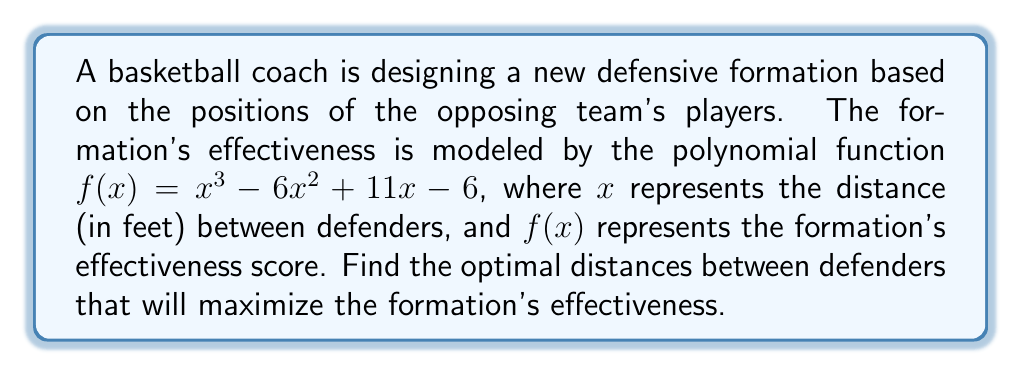Give your solution to this math problem. To find the optimal distances between defenders, we need to find the roots of the polynomial function $f(x) = x^3 - 6x^2 + 11x - 6$. These roots will give us the values of $x$ where the formation's effectiveness is zero, and the optimal distances will be between these values.

Let's solve this step-by-step:

1) First, we can try to factor out a common factor:
   $f(x) = x^3 - 6x^2 + 11x - 6$
   There are no common factors, so we move to the next step.

2) This is a cubic function, so let's try to guess one root. We can see that when $x = 1$, $f(1) = 1 - 6 + 11 - 6 = 0$. So, $(x - 1)$ is a factor.

3) We can use polynomial long division to divide $f(x)$ by $(x - 1)$:

   $x^3 - 6x^2 + 11x - 6 = (x - 1)(x^2 - 5x + 6)$

4) Now we need to factor the quadratic term $x^2 - 5x + 6$:
   $x^2 - 5x + 6 = (x - 2)(x - 3)$

5) Therefore, the fully factored polynomial is:
   $f(x) = (x - 1)(x - 2)(x - 3)$

6) The roots of the polynomial are the values that make each factor equal to zero:
   $x = 1$, $x = 2$, and $x = 3$

These roots represent the distances between defenders where the formation's effectiveness is zero. The optimal distances will be between these values, likely around 1.5 feet and 2.5 feet.
Answer: The roots of the polynomial are $x = 1$, $x = 2$, and $x = 3$. The optimal distances between defenders are likely to be around 1.5 feet and 2.5 feet. 